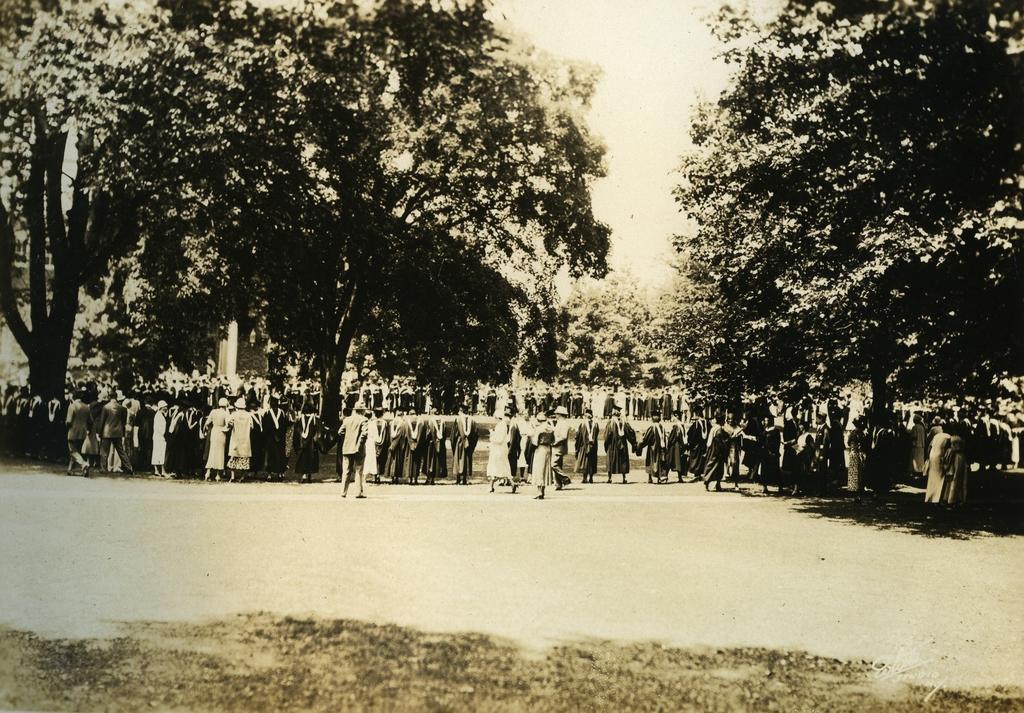Could you give a brief overview of what you see in this image? In the image we can see there are many people standing and some of them are walking, they are wearing clothes and some of them are wearing caps. Here we can see the road, grass, trees and the sky. 